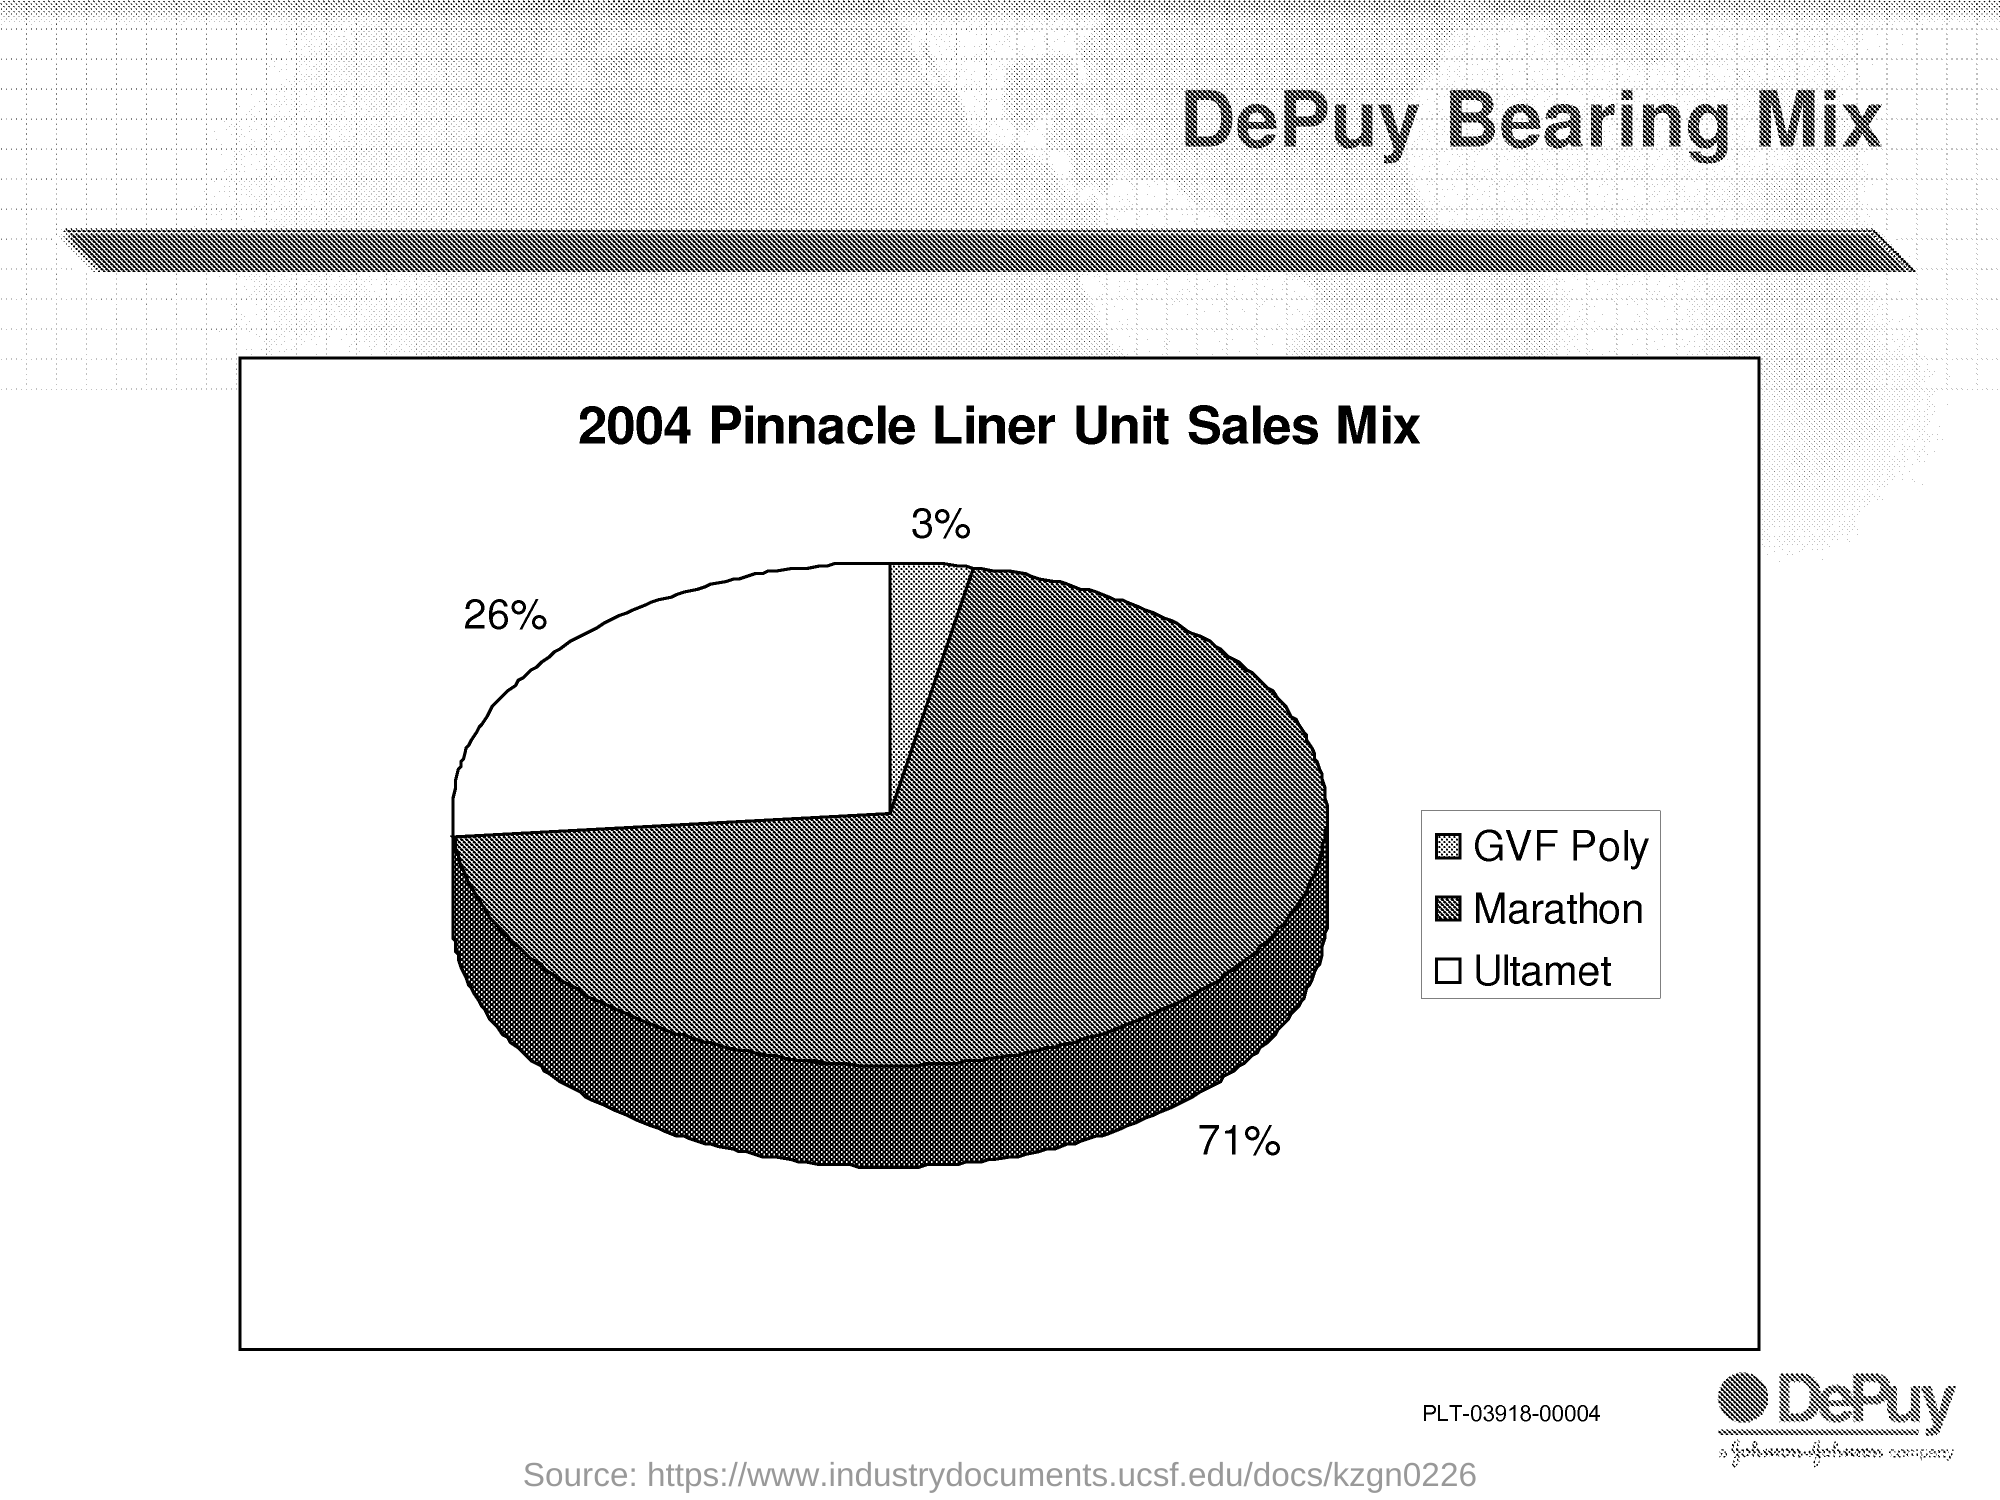Indicate a few pertinent items in this graphic. The pie chart shows that 3% of GVF Poly was given. The pie chart shows that 71% of the marathon participants completed the race. The pie chart shows that 26% of the sample includes Ultamet. 